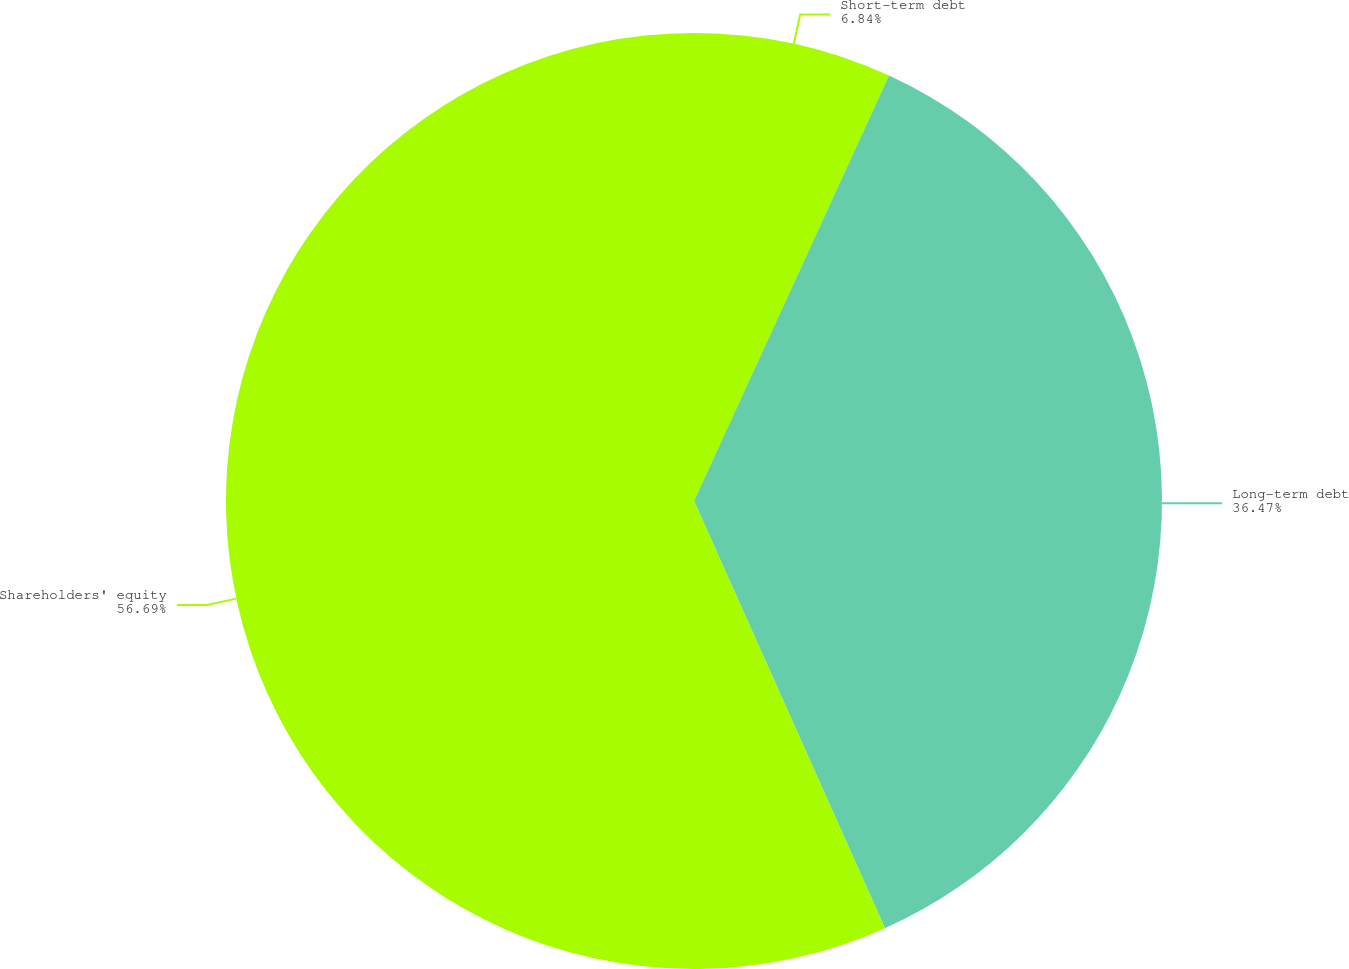Convert chart to OTSL. <chart><loc_0><loc_0><loc_500><loc_500><pie_chart><fcel>Short-term debt<fcel>Long-term debt<fcel>Shareholders' equity<nl><fcel>6.84%<fcel>36.47%<fcel>56.69%<nl></chart> 